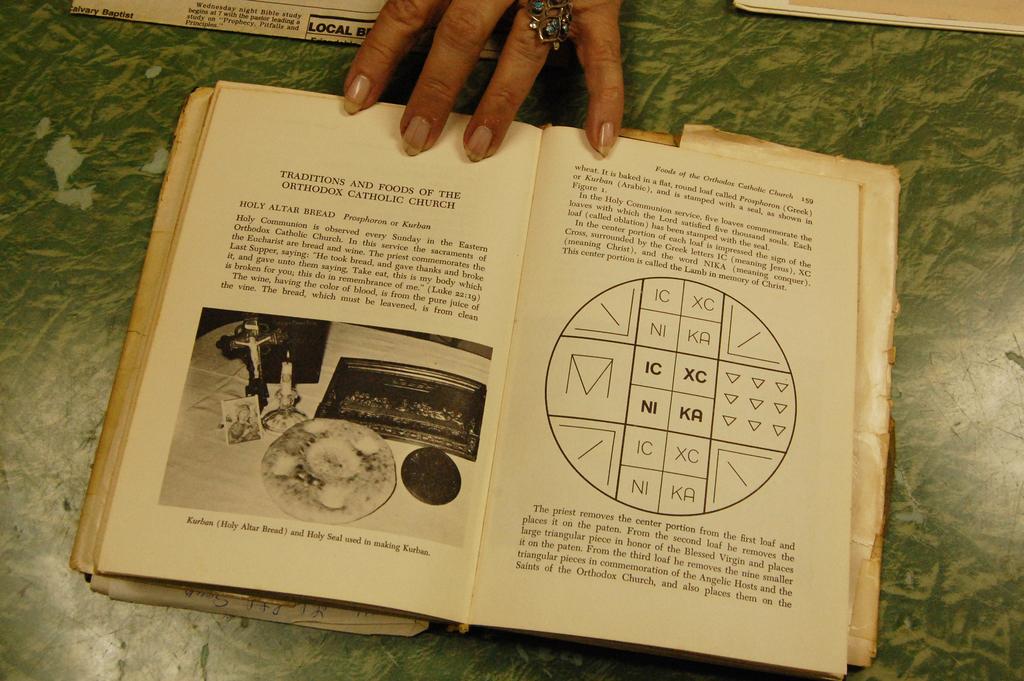What is the title of this chapter?
Ensure brevity in your answer.  Traditions and foods of the orthodox catholic church. What is written on the top of the left page?
Provide a succinct answer. Traditions and foods of the orthodox catholic church. 